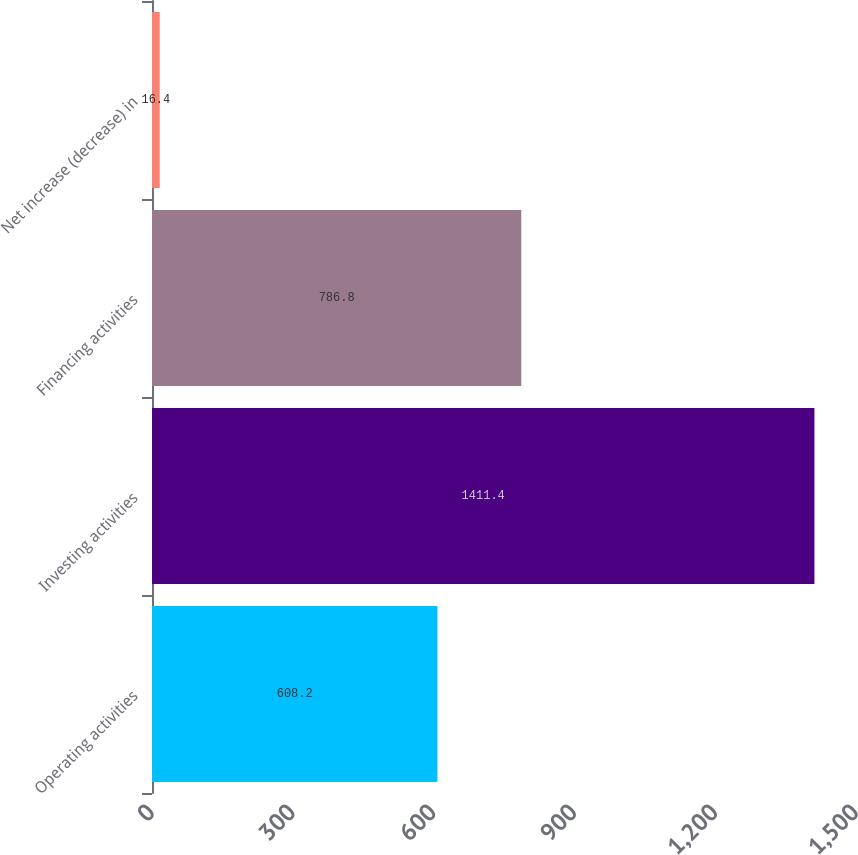Convert chart to OTSL. <chart><loc_0><loc_0><loc_500><loc_500><bar_chart><fcel>Operating activities<fcel>Investing activities<fcel>Financing activities<fcel>Net increase (decrease) in<nl><fcel>608.2<fcel>1411.4<fcel>786.8<fcel>16.4<nl></chart> 